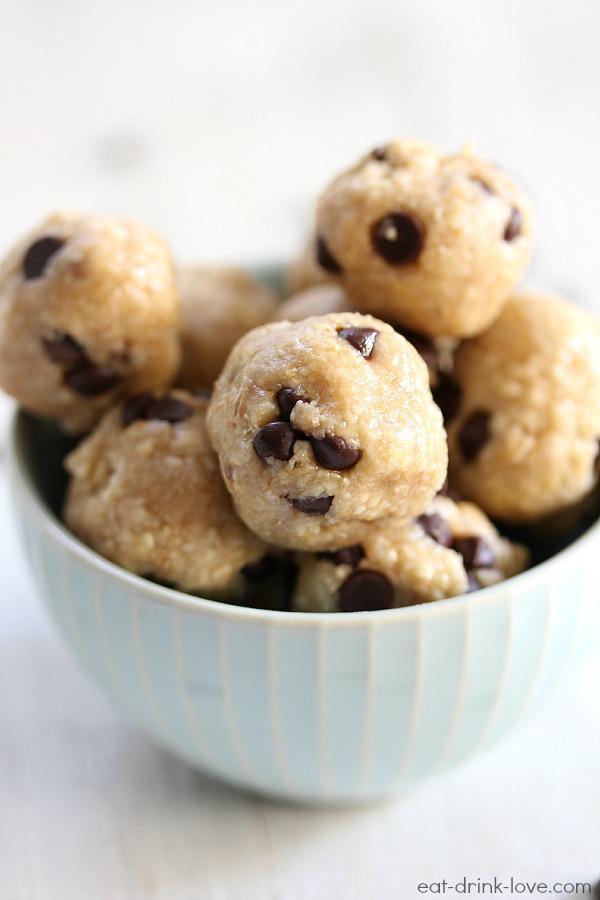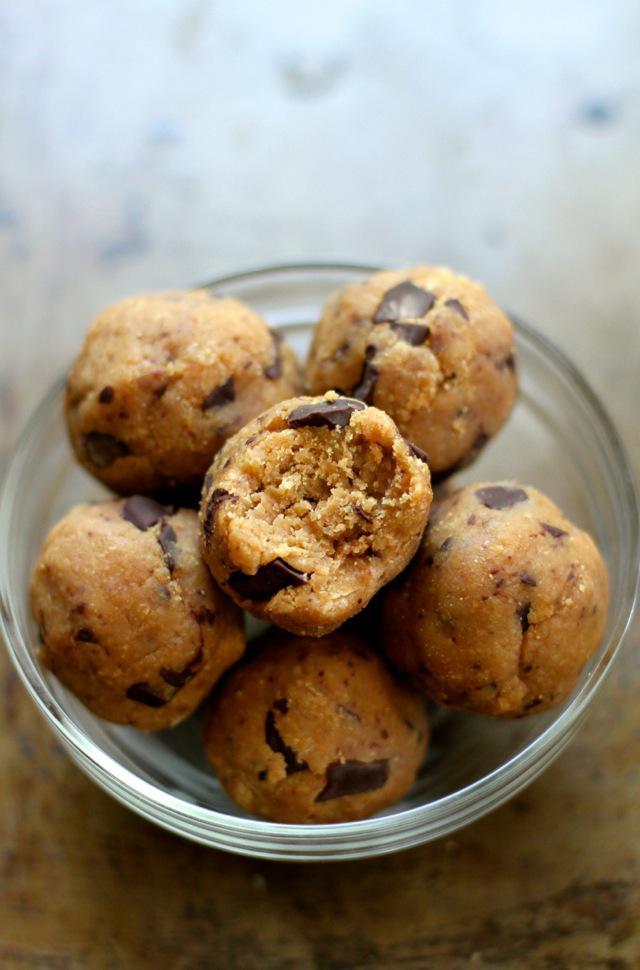The first image is the image on the left, the second image is the image on the right. Examine the images to the left and right. Is the description "The cookies in the left image are resting in a white dish." accurate? Answer yes or no. Yes. The first image is the image on the left, the second image is the image on the right. Examine the images to the left and right. Is the description "Every photo shows balls of dough inside of a bowl." accurate? Answer yes or no. Yes. 